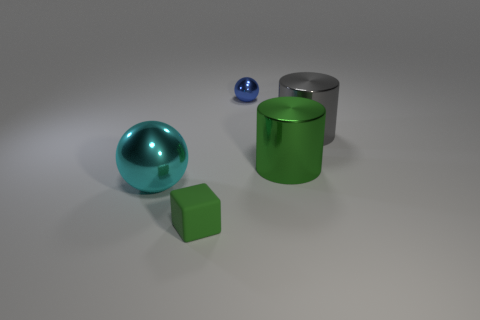Add 5 large green cylinders. How many objects exist? 10 Subtract all cylinders. How many objects are left? 3 Add 5 large shiny cylinders. How many large shiny cylinders are left? 7 Add 4 gray balls. How many gray balls exist? 4 Subtract 0 green balls. How many objects are left? 5 Subtract all small gray balls. Subtract all big spheres. How many objects are left? 4 